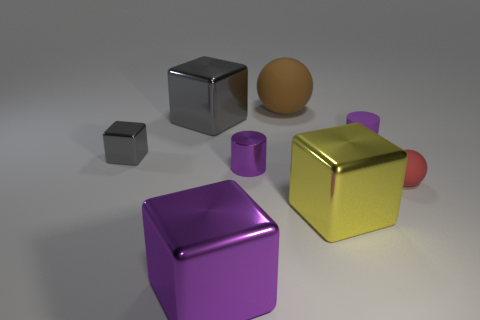Subtract all brown cylinders. Subtract all brown cubes. How many cylinders are left? 2 Add 2 large matte spheres. How many objects exist? 10 Add 7 large cubes. How many large cubes exist? 10 Subtract 2 purple cylinders. How many objects are left? 6 Subtract all purple blocks. Subtract all gray shiny cubes. How many objects are left? 5 Add 3 big yellow metal cubes. How many big yellow metal cubes are left? 4 